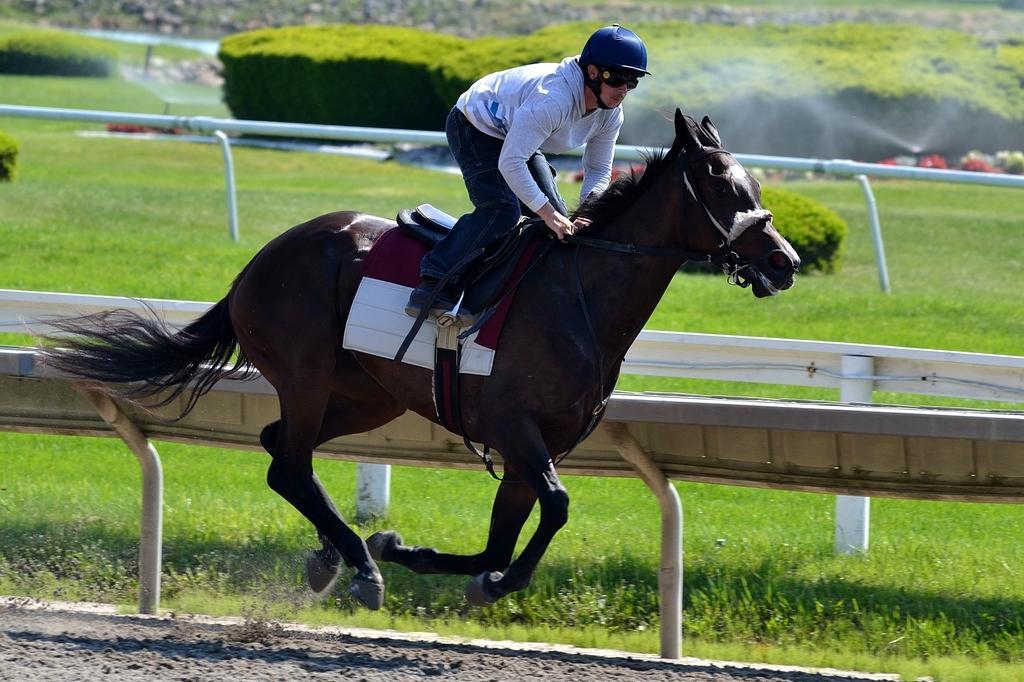How would you summarize this image in a sentence or two? In this image I can see the ground and a person riding a horse. In the background I can see the railing, few pipes, some grass, the water sprinkler and few trees which are green in color. 